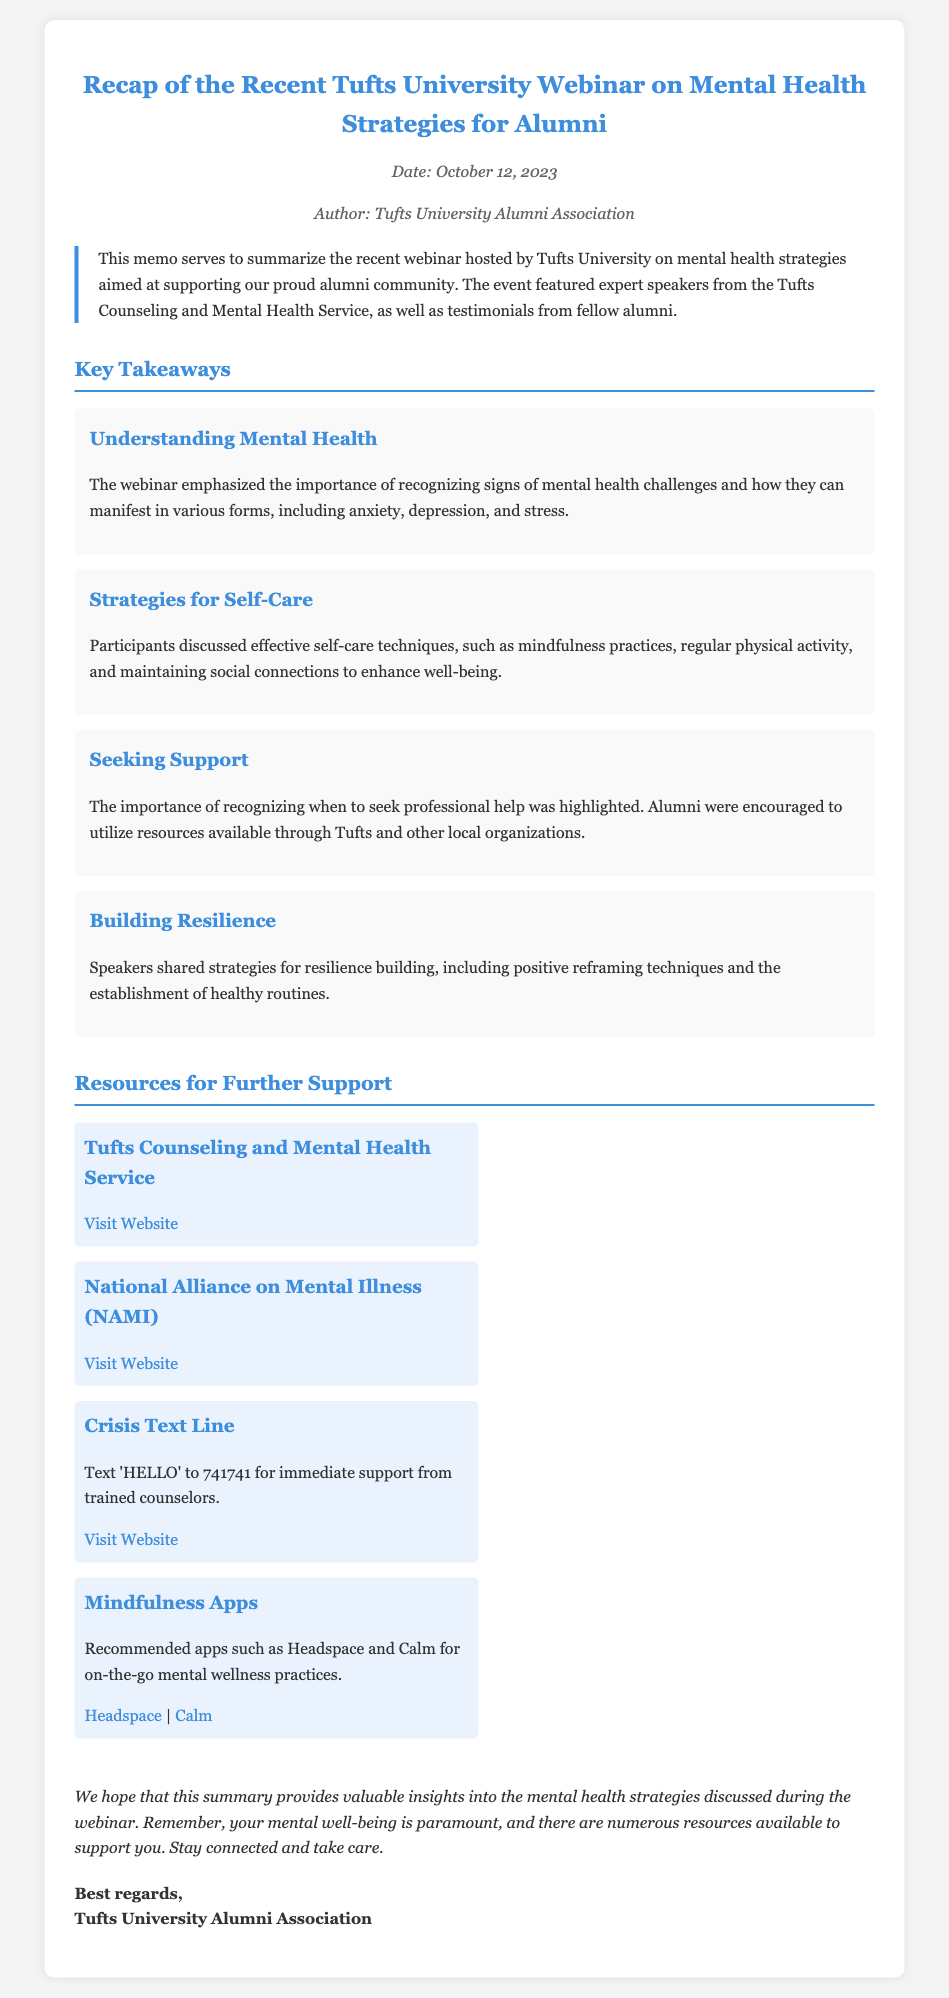What is the date of the webinar? The date of the webinar is mentioned in the document under the meta section.
Answer: October 12, 2023 Who authored the memo? The author of the memo is specified in the meta section of the document.
Answer: Tufts University Alumni Association What is emphasized as a key mental health strategy in the webinar? The document lists several key takeaways, one of which emphasizes the importance of recognizing signs of mental health challenges.
Answer: Understanding Mental Health What is the recommended text for immediate support via the Crisis Text Line? The document provides specific text instructions in the resources section for immediate support.
Answer: 'HELLO' Which organization is recommended for mental health support aside from Tufts? The document mentions additional organizations in the resources section.
Answer: National Alliance on Mental Illness (NAMI) What is one self-care technique discussed in the webinar? The document lists various self-care techniques discussed, one of which is highlighted in the takeaways section.
Answer: Mindfulness practices What is the main purpose of the memo? The purpose of the memo is stated in the introduction section of the document.
Answer: To summarize the recent webinar What types of resources are suggested for further support? The document details various types of resources available for alumni to seek support.
Answer: Websites and apps 